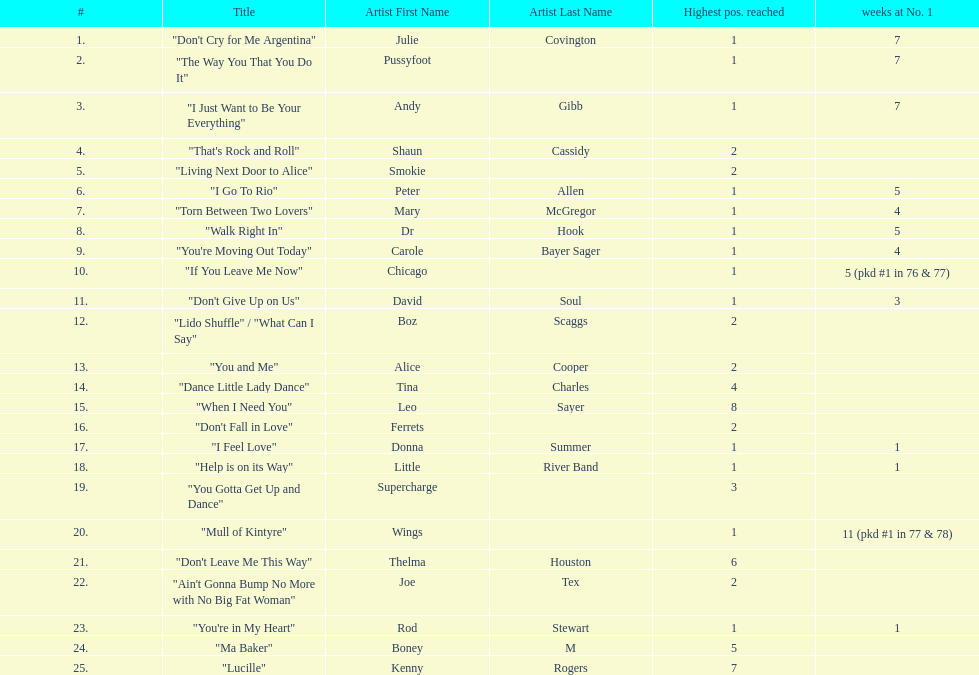Which song stayed at no.1 for the most amount of weeks. "Mull of Kintyre". Could you parse the entire table as a dict? {'header': ['#', 'Title', 'Artist First Name', 'Artist Last Name', 'Highest pos. reached', 'weeks at No. 1'], 'rows': [['1.', '"Don\'t Cry for Me Argentina"', 'Julie', 'Covington', '1', '7'], ['2.', '"The Way You That You Do It"', 'Pussyfoot', '', '1', '7'], ['3.', '"I Just Want to Be Your Everything"', 'Andy', 'Gibb', '1', '7'], ['4.', '"That\'s Rock and Roll"', 'Shaun', 'Cassidy', '2', ''], ['5.', '"Living Next Door to Alice"', 'Smokie', '', '2', ''], ['6.', '"I Go To Rio"', 'Peter', 'Allen', '1', '5'], ['7.', '"Torn Between Two Lovers"', 'Mary', 'McGregor', '1', '4'], ['8.', '"Walk Right In"', 'Dr', 'Hook', '1', '5'], ['9.', '"You\'re Moving Out Today"', 'Carole', 'Bayer Sager', '1', '4'], ['10.', '"If You Leave Me Now"', 'Chicago', '', '1', '5 (pkd #1 in 76 & 77)'], ['11.', '"Don\'t Give Up on Us"', 'David', 'Soul', '1', '3'], ['12.', '"Lido Shuffle" / "What Can I Say"', 'Boz', 'Scaggs', '2', ''], ['13.', '"You and Me"', 'Alice', 'Cooper', '2', ''], ['14.', '"Dance Little Lady Dance"', 'Tina', 'Charles', '4', ''], ['15.', '"When I Need You"', 'Leo', 'Sayer', '8', ''], ['16.', '"Don\'t Fall in Love"', 'Ferrets', '', '2', ''], ['17.', '"I Feel Love"', 'Donna', 'Summer', '1', '1'], ['18.', '"Help is on its Way"', 'Little', 'River Band', '1', '1'], ['19.', '"You Gotta Get Up and Dance"', 'Supercharge', '', '3', ''], ['20.', '"Mull of Kintyre"', 'Wings', '', '1', '11 (pkd #1 in 77 & 78)'], ['21.', '"Don\'t Leave Me This Way"', 'Thelma', 'Houston', '6', ''], ['22.', '"Ain\'t Gonna Bump No More with No Big Fat Woman"', 'Joe', 'Tex', '2', ''], ['23.', '"You\'re in My Heart"', 'Rod', 'Stewart', '1', '1'], ['24.', '"Ma Baker"', 'Boney', 'M', '5', ''], ['25.', '"Lucille"', 'Kenny', 'Rogers', '7', '']]} 